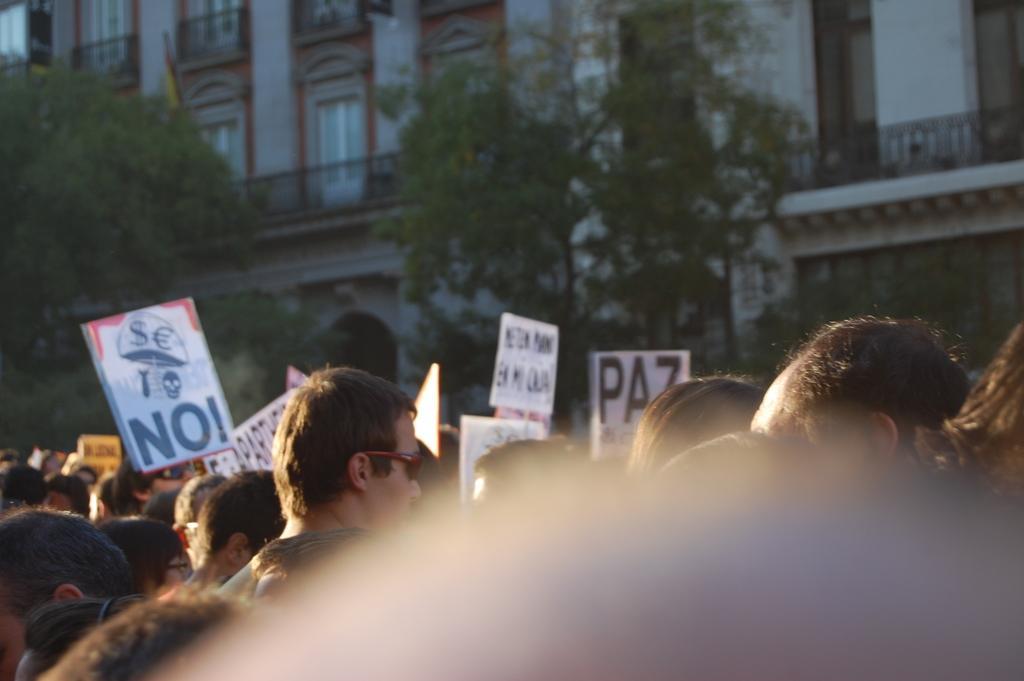Could you give a brief overview of what you see in this image? In this image, we can see some people standing and we can see some posters, there are some trees and we can see buildings and there are some windows on the buildings. 